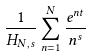Convert formula to latex. <formula><loc_0><loc_0><loc_500><loc_500>\frac { 1 } { H _ { N , s } } \sum _ { n = 1 } ^ { N } \frac { e ^ { n t } } { n ^ { s } }</formula> 